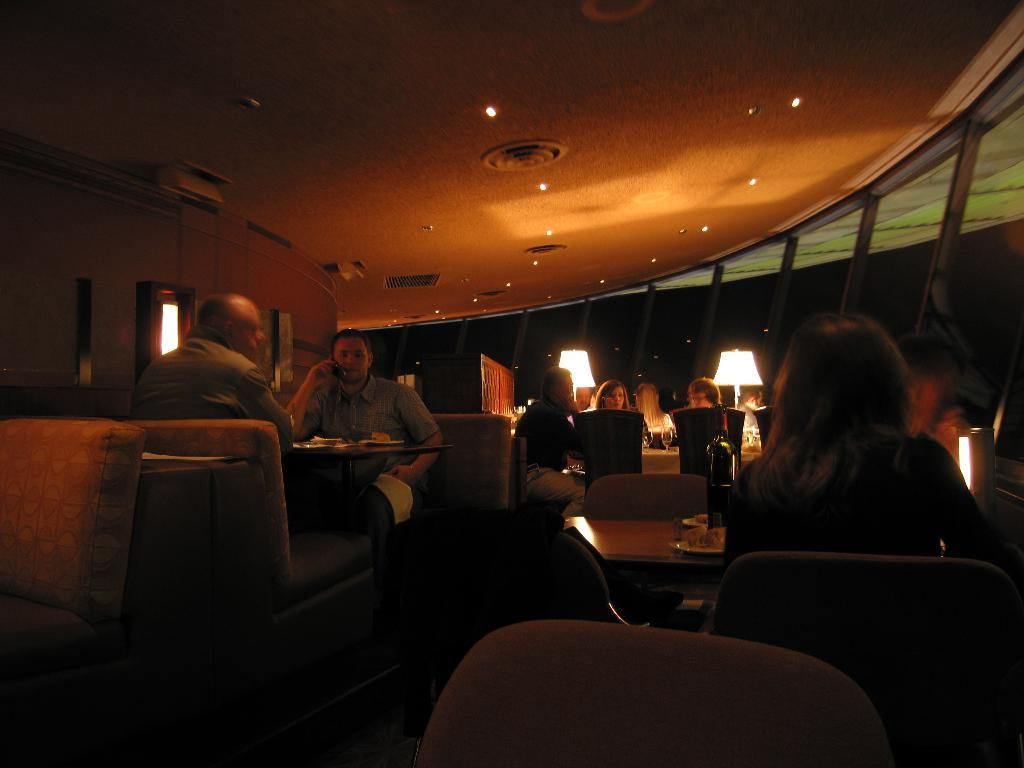What are the people in the image doing? People are sitting on chairs in the image. What is in front of the chairs? There are tables in front of the chairs. What can be seen on the tables? There is a bottle, plates, and other objects on the tables. How far away from the tables are the lamps? The lamps are far from the tables in the image. What type of windows are present in the image? There are glass windows in the image. What type of home security system is installed in the image? There is no mention of a home security system in the image. 